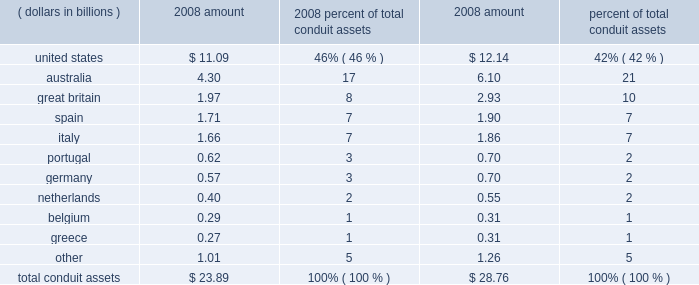Conduit assets by asset origin .
The conduits meet the definition of a vie , as defined by fin 46 ( r ) .
We have determined that we are not the primary beneficiary of the conduits , as defined by fin 46 ( r ) , and do not record them in our consolidated financial statements .
We hold no direct or indirect ownership interest in the conduits , but we provide subordinated financial support to them through contractual arrangements .
Standby letters of credit absorb certain actual credit losses from the conduit assets ; our commitment under these letters of credit totaled $ 1.00 billion and $ 1.04 billion at december 31 , 2008 and 2007 , respectively .
Liquidity asset purchase agreements provide liquidity to the conduits in the event they cannot place commercial paper in the ordinary course of their business ; these facilities , which require us to purchase assets from the conduits at par , would provide the needed liquidity to repay maturing commercial paper if there was a disruption in the asset-backed commercial paper market .
The aggregate commitment under the liquidity asset purchase agreements was approximately $ 23.59 billion and $ 28.37 billion at december 31 , 2008 and 2007 , respectively .
We did not accrue for any losses associated with either our commitment under the standby letters of credit or the liquidity asset purchase agreements in our consolidated statement of condition at december 31 , 2008 or 2007 .
During the first quarter of 2008 , pursuant to the contractual terms of our liquidity asset purchase agreements with the conduits , we were required to purchase $ 850 million of conduit assets .
The purchase was the result of various factors , including the continued illiquidity in the commercial paper markets .
The securities were purchased at prices determined in accordance with existing contractual terms in the liquidity asset purchase agreements , and which exceeded their fair value .
Accordingly , during the first quarter of 2008 , the securities were written down to their fair value through a $ 12 million reduction of processing fees and other revenue in our consolidated statement of income , and are carried at fair value in securities available for sale in our consolidated statement of condition .
None of our liquidity asset purchase agreements with the conduits were drawn upon during the remainder of 2008 , and no draw-downs on the standby letters of credit occurred during 2008 .
The conduits generally sell commercial paper to independent third-party investors .
However , we sometimes purchase commercial paper from the conduits .
As of december 31 , 2008 , we held an aggregate of approximately $ 230 million of commercial paper issued by the conduits , and $ 2 million at december 31 , 2007 .
In addition , approximately $ 5.70 billion of u.s .
Conduit-issued commercial paper had been sold to the cpff .
The cpff is scheduled to expire on october 31 , 2009 .
The weighted-average maturity of the conduits 2019 commercial paper in the aggregate was approximately 25 days as of december 31 , 2008 , compared to approximately 20 days as of december 31 , 2007 .
Each of the conduits has issued first-loss notes to independent third parties , which third parties absorb first- dollar losses related to credit risk .
Aggregate first-loss notes outstanding at december 31 , 2008 for the four conduits totaled $ 67 million , compared to $ 32 million at december 31 , 2007 .
Actual credit losses of the conduits .
What is percentage change in total conduit asset from 2007 to 2008? 
Computations: ((23.59 - 28.37) / 28.37)
Answer: -0.16849. 